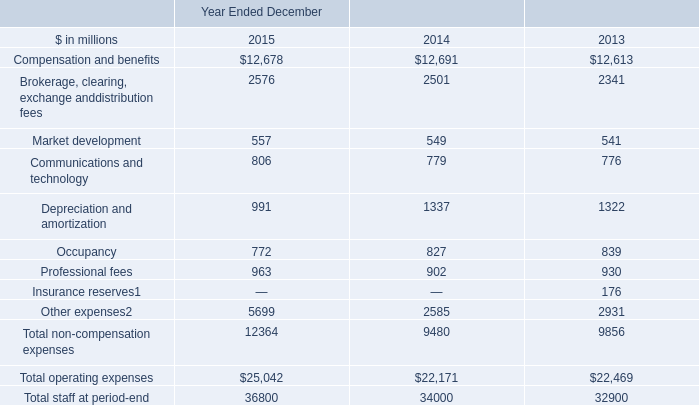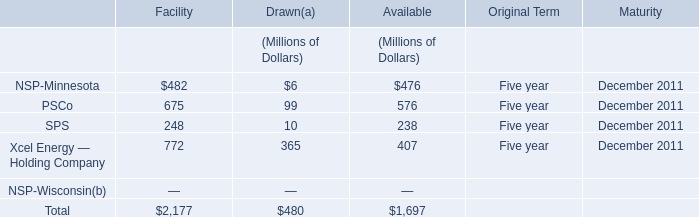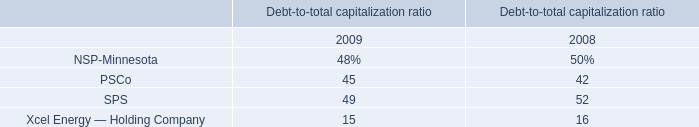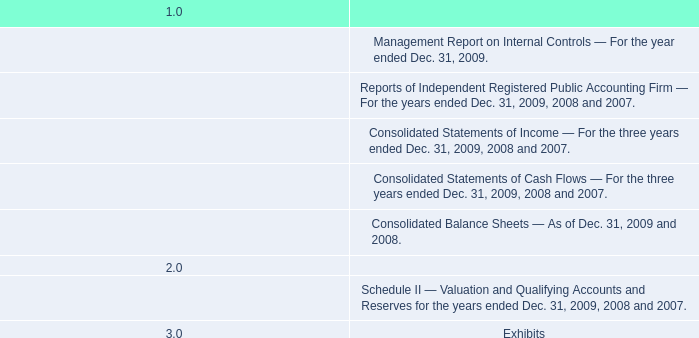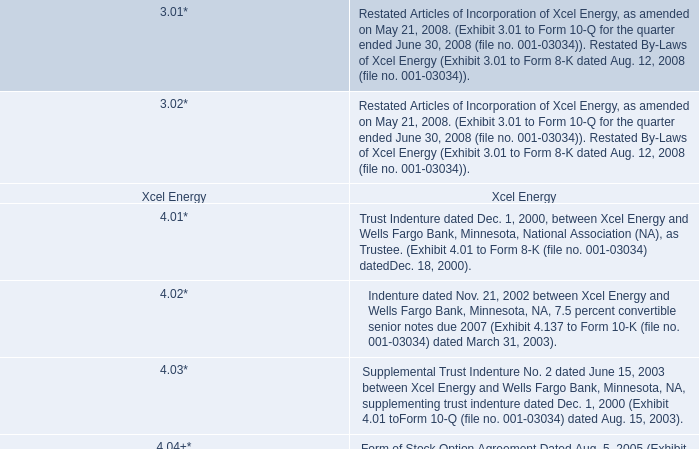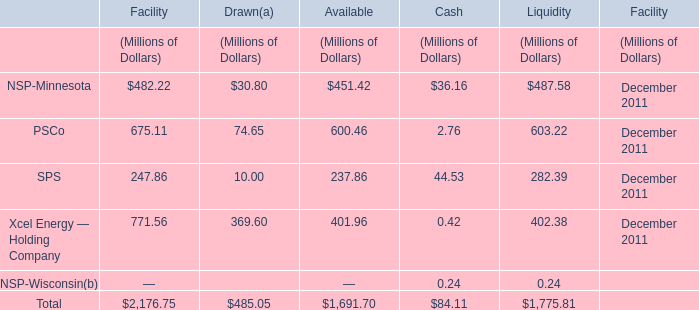What is the ratio of all elements that are smaller than 100 to the sum of elements, in Drawn? 
Computations: (((30.8 + 74.65) + 10) / 485.05)
Answer: 0.23802. 